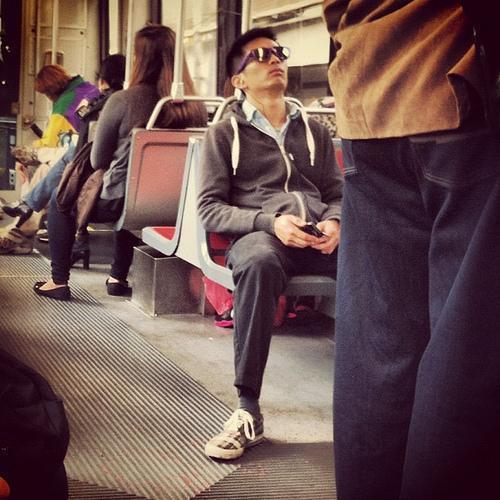How many people are seen in the photo?
Give a very brief answer. 5. How many pockets does the standing guy have on his jeans?
Give a very brief answer. 2. 